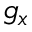Convert formula to latex. <formula><loc_0><loc_0><loc_500><loc_500>g _ { x }</formula> 